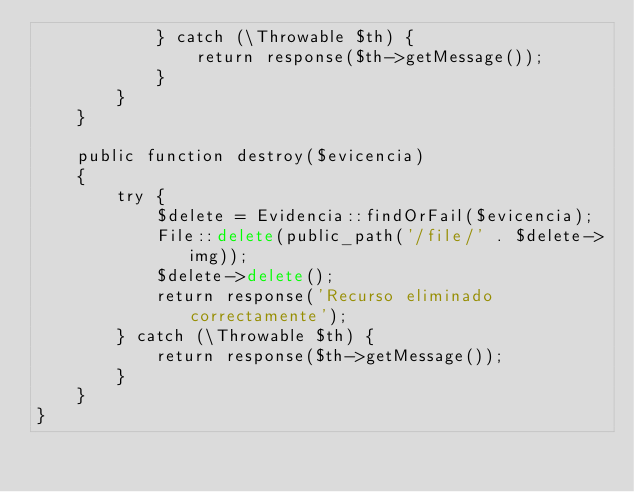<code> <loc_0><loc_0><loc_500><loc_500><_PHP_>            } catch (\Throwable $th) {
                return response($th->getMessage());
            }
        }
    }

    public function destroy($evicencia)
    {
        try {
            $delete = Evidencia::findOrFail($evicencia);
            File::delete(public_path('/file/' . $delete->img));
            $delete->delete();
            return response('Recurso eliminado correctamente');
        } catch (\Throwable $th) {
            return response($th->getMessage());
        }
    }
}
</code> 